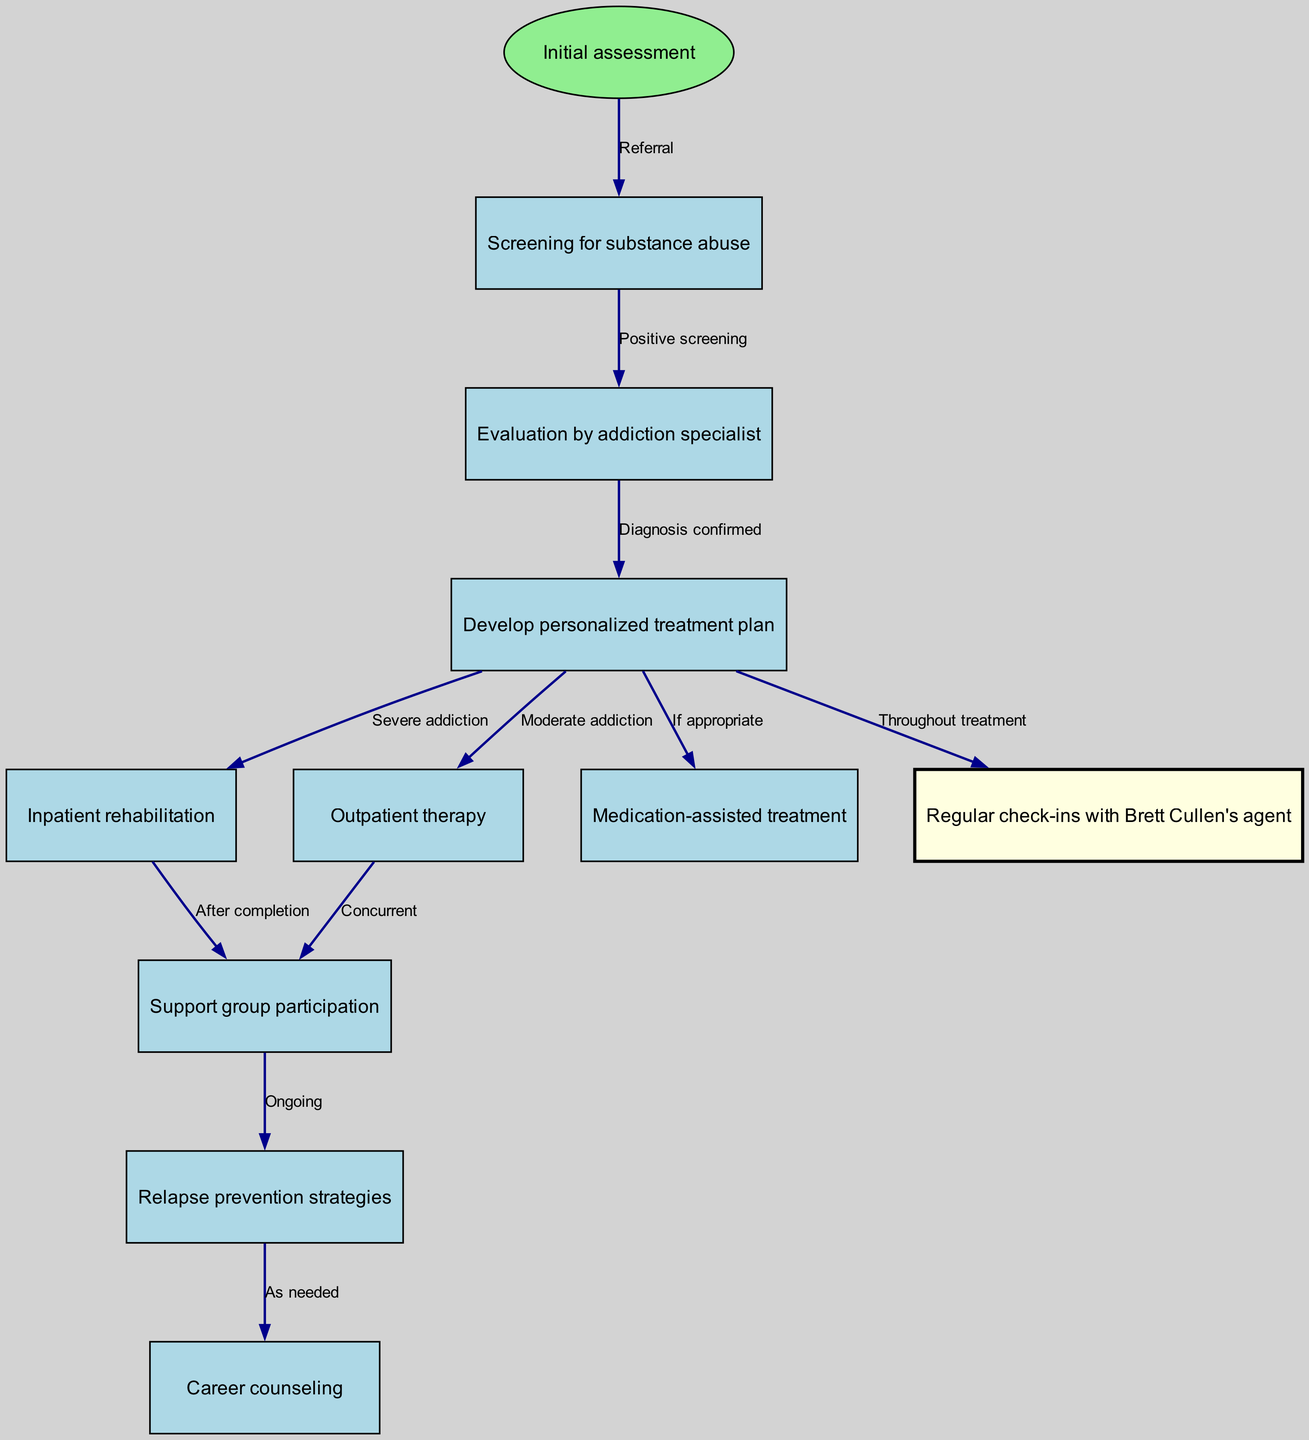What is the first step in the clinical pathway? The first step is "Initial assessment," which is indicated in the diagram as the starting node.
Answer: Initial assessment How many nodes are present in the diagram? By counting each distinct step in the pathway represented in the nodes section of the diagram, we find there are 10 nodes in total.
Answer: 10 What type of treatment follows the "Develop personalized treatment plan" node for severe addiction? For severe addiction, the diagram shows that the next step is "Inpatient rehabilitation," according to the connection from node 3 to node 4.
Answer: Inpatient rehabilitation Which node refers to ongoing participation in support groups? The node that refers to ongoing participation is "Support group participation," which is node 6 in the diagram.
Answer: Support group participation What action is taken if the treatment plan suggests medication-assisted treatment? If the treatment plan suggests medication-assisted treatment, the pathway indicates this should occur "If appropriate" following the "Develop personalized treatment plan."
Answer: If appropriate What connects 'Regular check-ins with Brett Cullen's agent' to 'Relapse prevention strategies'? The connection is indicated in the diagram as "Ongoing," which leads from node 6 (Regular check-ins with Brett Cullen's agent) to node 9 (Relapse prevention strategies).
Answer: Ongoing How do patients transition from outpatient therapy in the pathway? Patients transition from "Outpatient therapy" to "Support group participation" as indicated in the pathway with the label "Concurrent."
Answer: Concurrent Which node is highlighted as important throughout the treatment? The node "Regular check-ins with Brett Cullen's agent" is highlighted as important throughout treatment, indicated by its special color in the diagram.
Answer: Regular check-ins with Brett Cullen's agent 